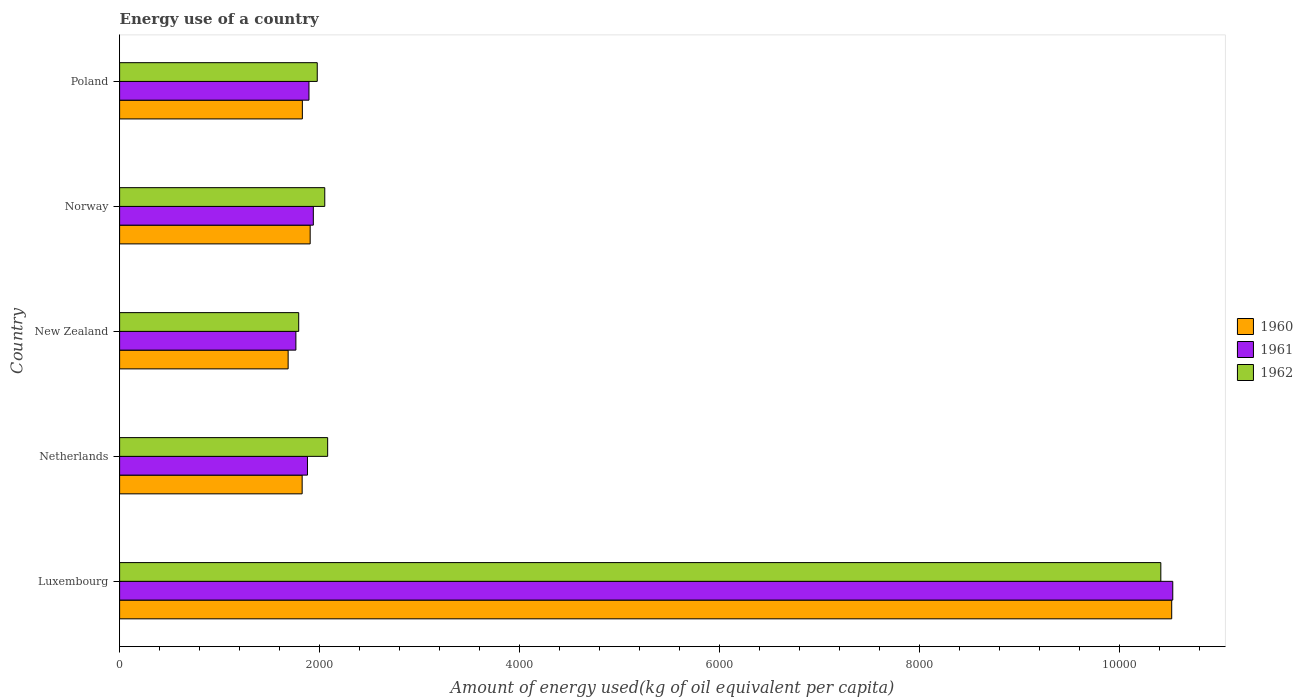How many groups of bars are there?
Provide a short and direct response. 5. Are the number of bars per tick equal to the number of legend labels?
Keep it short and to the point. Yes. Are the number of bars on each tick of the Y-axis equal?
Keep it short and to the point. Yes. How many bars are there on the 3rd tick from the top?
Offer a terse response. 3. In how many cases, is the number of bars for a given country not equal to the number of legend labels?
Offer a terse response. 0. What is the amount of energy used in in 1962 in Netherlands?
Make the answer very short. 2081.01. Across all countries, what is the maximum amount of energy used in in 1961?
Make the answer very short. 1.05e+04. Across all countries, what is the minimum amount of energy used in in 1960?
Offer a terse response. 1685.79. In which country was the amount of energy used in in 1960 maximum?
Provide a succinct answer. Luxembourg. In which country was the amount of energy used in in 1961 minimum?
Keep it short and to the point. New Zealand. What is the total amount of energy used in in 1960 in the graph?
Offer a very short reply. 1.78e+04. What is the difference between the amount of energy used in in 1960 in New Zealand and that in Norway?
Offer a very short reply. -220.39. What is the difference between the amount of energy used in in 1960 in Luxembourg and the amount of energy used in in 1961 in Norway?
Keep it short and to the point. 8585.76. What is the average amount of energy used in in 1961 per country?
Ensure brevity in your answer.  3601.63. What is the difference between the amount of energy used in in 1962 and amount of energy used in in 1961 in New Zealand?
Ensure brevity in your answer.  28.2. In how many countries, is the amount of energy used in in 1960 greater than 7600 kg?
Your answer should be compact. 1. What is the ratio of the amount of energy used in in 1960 in Norway to that in Poland?
Ensure brevity in your answer.  1.04. What is the difference between the highest and the second highest amount of energy used in in 1960?
Give a very brief answer. 8617.23. What is the difference between the highest and the lowest amount of energy used in in 1960?
Your response must be concise. 8837.62. Is the sum of the amount of energy used in in 1960 in Norway and Poland greater than the maximum amount of energy used in in 1961 across all countries?
Provide a succinct answer. No. What does the 1st bar from the top in Norway represents?
Offer a very short reply. 1962. How many bars are there?
Your answer should be compact. 15. How many countries are there in the graph?
Give a very brief answer. 5. What is the difference between two consecutive major ticks on the X-axis?
Offer a very short reply. 2000. Does the graph contain any zero values?
Ensure brevity in your answer.  No. Where does the legend appear in the graph?
Provide a short and direct response. Center right. What is the title of the graph?
Your response must be concise. Energy use of a country. Does "1972" appear as one of the legend labels in the graph?
Your answer should be very brief. No. What is the label or title of the X-axis?
Offer a very short reply. Amount of energy used(kg of oil equivalent per capita). What is the Amount of energy used(kg of oil equivalent per capita) in 1960 in Luxembourg?
Make the answer very short. 1.05e+04. What is the Amount of energy used(kg of oil equivalent per capita) of 1961 in Luxembourg?
Give a very brief answer. 1.05e+04. What is the Amount of energy used(kg of oil equivalent per capita) of 1962 in Luxembourg?
Keep it short and to the point. 1.04e+04. What is the Amount of energy used(kg of oil equivalent per capita) in 1960 in Netherlands?
Offer a very short reply. 1825.93. What is the Amount of energy used(kg of oil equivalent per capita) in 1961 in Netherlands?
Offer a very short reply. 1879.15. What is the Amount of energy used(kg of oil equivalent per capita) of 1962 in Netherlands?
Ensure brevity in your answer.  2081.01. What is the Amount of energy used(kg of oil equivalent per capita) in 1960 in New Zealand?
Provide a short and direct response. 1685.79. What is the Amount of energy used(kg of oil equivalent per capita) in 1961 in New Zealand?
Your answer should be very brief. 1763.26. What is the Amount of energy used(kg of oil equivalent per capita) in 1962 in New Zealand?
Make the answer very short. 1791.46. What is the Amount of energy used(kg of oil equivalent per capita) of 1960 in Norway?
Offer a terse response. 1906.17. What is the Amount of energy used(kg of oil equivalent per capita) of 1961 in Norway?
Your response must be concise. 1937.64. What is the Amount of energy used(kg of oil equivalent per capita) in 1962 in Norway?
Make the answer very short. 2052.05. What is the Amount of energy used(kg of oil equivalent per capita) of 1960 in Poland?
Provide a succinct answer. 1827.94. What is the Amount of energy used(kg of oil equivalent per capita) in 1961 in Poland?
Give a very brief answer. 1894.06. What is the Amount of energy used(kg of oil equivalent per capita) of 1962 in Poland?
Ensure brevity in your answer.  1976.86. Across all countries, what is the maximum Amount of energy used(kg of oil equivalent per capita) in 1960?
Offer a terse response. 1.05e+04. Across all countries, what is the maximum Amount of energy used(kg of oil equivalent per capita) of 1961?
Your answer should be compact. 1.05e+04. Across all countries, what is the maximum Amount of energy used(kg of oil equivalent per capita) of 1962?
Your response must be concise. 1.04e+04. Across all countries, what is the minimum Amount of energy used(kg of oil equivalent per capita) in 1960?
Offer a very short reply. 1685.79. Across all countries, what is the minimum Amount of energy used(kg of oil equivalent per capita) in 1961?
Keep it short and to the point. 1763.26. Across all countries, what is the minimum Amount of energy used(kg of oil equivalent per capita) in 1962?
Provide a short and direct response. 1791.46. What is the total Amount of energy used(kg of oil equivalent per capita) of 1960 in the graph?
Give a very brief answer. 1.78e+04. What is the total Amount of energy used(kg of oil equivalent per capita) in 1961 in the graph?
Ensure brevity in your answer.  1.80e+04. What is the total Amount of energy used(kg of oil equivalent per capita) of 1962 in the graph?
Provide a succinct answer. 1.83e+04. What is the difference between the Amount of energy used(kg of oil equivalent per capita) of 1960 in Luxembourg and that in Netherlands?
Give a very brief answer. 8697.47. What is the difference between the Amount of energy used(kg of oil equivalent per capita) of 1961 in Luxembourg and that in Netherlands?
Your answer should be very brief. 8654.87. What is the difference between the Amount of energy used(kg of oil equivalent per capita) in 1962 in Luxembourg and that in Netherlands?
Offer a terse response. 8333.53. What is the difference between the Amount of energy used(kg of oil equivalent per capita) in 1960 in Luxembourg and that in New Zealand?
Give a very brief answer. 8837.62. What is the difference between the Amount of energy used(kg of oil equivalent per capita) of 1961 in Luxembourg and that in New Zealand?
Ensure brevity in your answer.  8770.76. What is the difference between the Amount of energy used(kg of oil equivalent per capita) in 1962 in Luxembourg and that in New Zealand?
Offer a terse response. 8623.08. What is the difference between the Amount of energy used(kg of oil equivalent per capita) in 1960 in Luxembourg and that in Norway?
Give a very brief answer. 8617.23. What is the difference between the Amount of energy used(kg of oil equivalent per capita) of 1961 in Luxembourg and that in Norway?
Keep it short and to the point. 8596.37. What is the difference between the Amount of energy used(kg of oil equivalent per capita) in 1962 in Luxembourg and that in Norway?
Your response must be concise. 8362.49. What is the difference between the Amount of energy used(kg of oil equivalent per capita) in 1960 in Luxembourg and that in Poland?
Give a very brief answer. 8695.47. What is the difference between the Amount of energy used(kg of oil equivalent per capita) in 1961 in Luxembourg and that in Poland?
Your response must be concise. 8639.96. What is the difference between the Amount of energy used(kg of oil equivalent per capita) in 1962 in Luxembourg and that in Poland?
Ensure brevity in your answer.  8437.68. What is the difference between the Amount of energy used(kg of oil equivalent per capita) in 1960 in Netherlands and that in New Zealand?
Keep it short and to the point. 140.15. What is the difference between the Amount of energy used(kg of oil equivalent per capita) of 1961 in Netherlands and that in New Zealand?
Ensure brevity in your answer.  115.89. What is the difference between the Amount of energy used(kg of oil equivalent per capita) of 1962 in Netherlands and that in New Zealand?
Your answer should be very brief. 289.55. What is the difference between the Amount of energy used(kg of oil equivalent per capita) of 1960 in Netherlands and that in Norway?
Offer a very short reply. -80.24. What is the difference between the Amount of energy used(kg of oil equivalent per capita) of 1961 in Netherlands and that in Norway?
Your answer should be compact. -58.49. What is the difference between the Amount of energy used(kg of oil equivalent per capita) in 1962 in Netherlands and that in Norway?
Offer a very short reply. 28.96. What is the difference between the Amount of energy used(kg of oil equivalent per capita) in 1960 in Netherlands and that in Poland?
Your response must be concise. -2. What is the difference between the Amount of energy used(kg of oil equivalent per capita) in 1961 in Netherlands and that in Poland?
Your response must be concise. -14.91. What is the difference between the Amount of energy used(kg of oil equivalent per capita) of 1962 in Netherlands and that in Poland?
Your answer should be very brief. 104.15. What is the difference between the Amount of energy used(kg of oil equivalent per capita) of 1960 in New Zealand and that in Norway?
Your answer should be compact. -220.39. What is the difference between the Amount of energy used(kg of oil equivalent per capita) of 1961 in New Zealand and that in Norway?
Offer a terse response. -174.38. What is the difference between the Amount of energy used(kg of oil equivalent per capita) of 1962 in New Zealand and that in Norway?
Give a very brief answer. -260.59. What is the difference between the Amount of energy used(kg of oil equivalent per capita) in 1960 in New Zealand and that in Poland?
Provide a short and direct response. -142.15. What is the difference between the Amount of energy used(kg of oil equivalent per capita) of 1961 in New Zealand and that in Poland?
Offer a terse response. -130.8. What is the difference between the Amount of energy used(kg of oil equivalent per capita) in 1962 in New Zealand and that in Poland?
Provide a succinct answer. -185.4. What is the difference between the Amount of energy used(kg of oil equivalent per capita) in 1960 in Norway and that in Poland?
Give a very brief answer. 78.24. What is the difference between the Amount of energy used(kg of oil equivalent per capita) of 1961 in Norway and that in Poland?
Provide a short and direct response. 43.59. What is the difference between the Amount of energy used(kg of oil equivalent per capita) of 1962 in Norway and that in Poland?
Provide a short and direct response. 75.19. What is the difference between the Amount of energy used(kg of oil equivalent per capita) in 1960 in Luxembourg and the Amount of energy used(kg of oil equivalent per capita) in 1961 in Netherlands?
Provide a short and direct response. 8644.26. What is the difference between the Amount of energy used(kg of oil equivalent per capita) in 1960 in Luxembourg and the Amount of energy used(kg of oil equivalent per capita) in 1962 in Netherlands?
Your response must be concise. 8442.4. What is the difference between the Amount of energy used(kg of oil equivalent per capita) in 1961 in Luxembourg and the Amount of energy used(kg of oil equivalent per capita) in 1962 in Netherlands?
Provide a succinct answer. 8453.01. What is the difference between the Amount of energy used(kg of oil equivalent per capita) of 1960 in Luxembourg and the Amount of energy used(kg of oil equivalent per capita) of 1961 in New Zealand?
Your answer should be very brief. 8760.15. What is the difference between the Amount of energy used(kg of oil equivalent per capita) of 1960 in Luxembourg and the Amount of energy used(kg of oil equivalent per capita) of 1962 in New Zealand?
Your response must be concise. 8731.95. What is the difference between the Amount of energy used(kg of oil equivalent per capita) of 1961 in Luxembourg and the Amount of energy used(kg of oil equivalent per capita) of 1962 in New Zealand?
Keep it short and to the point. 8742.56. What is the difference between the Amount of energy used(kg of oil equivalent per capita) of 1960 in Luxembourg and the Amount of energy used(kg of oil equivalent per capita) of 1961 in Norway?
Give a very brief answer. 8585.76. What is the difference between the Amount of energy used(kg of oil equivalent per capita) in 1960 in Luxembourg and the Amount of energy used(kg of oil equivalent per capita) in 1962 in Norway?
Provide a short and direct response. 8471.35. What is the difference between the Amount of energy used(kg of oil equivalent per capita) in 1961 in Luxembourg and the Amount of energy used(kg of oil equivalent per capita) in 1962 in Norway?
Provide a succinct answer. 8481.96. What is the difference between the Amount of energy used(kg of oil equivalent per capita) in 1960 in Luxembourg and the Amount of energy used(kg of oil equivalent per capita) in 1961 in Poland?
Keep it short and to the point. 8629.35. What is the difference between the Amount of energy used(kg of oil equivalent per capita) in 1960 in Luxembourg and the Amount of energy used(kg of oil equivalent per capita) in 1962 in Poland?
Offer a terse response. 8546.55. What is the difference between the Amount of energy used(kg of oil equivalent per capita) of 1961 in Luxembourg and the Amount of energy used(kg of oil equivalent per capita) of 1962 in Poland?
Your response must be concise. 8557.16. What is the difference between the Amount of energy used(kg of oil equivalent per capita) in 1960 in Netherlands and the Amount of energy used(kg of oil equivalent per capita) in 1961 in New Zealand?
Provide a short and direct response. 62.67. What is the difference between the Amount of energy used(kg of oil equivalent per capita) of 1960 in Netherlands and the Amount of energy used(kg of oil equivalent per capita) of 1962 in New Zealand?
Make the answer very short. 34.47. What is the difference between the Amount of energy used(kg of oil equivalent per capita) in 1961 in Netherlands and the Amount of energy used(kg of oil equivalent per capita) in 1962 in New Zealand?
Keep it short and to the point. 87.69. What is the difference between the Amount of energy used(kg of oil equivalent per capita) of 1960 in Netherlands and the Amount of energy used(kg of oil equivalent per capita) of 1961 in Norway?
Your answer should be compact. -111.71. What is the difference between the Amount of energy used(kg of oil equivalent per capita) of 1960 in Netherlands and the Amount of energy used(kg of oil equivalent per capita) of 1962 in Norway?
Your answer should be very brief. -226.12. What is the difference between the Amount of energy used(kg of oil equivalent per capita) of 1961 in Netherlands and the Amount of energy used(kg of oil equivalent per capita) of 1962 in Norway?
Your answer should be very brief. -172.9. What is the difference between the Amount of energy used(kg of oil equivalent per capita) in 1960 in Netherlands and the Amount of energy used(kg of oil equivalent per capita) in 1961 in Poland?
Make the answer very short. -68.12. What is the difference between the Amount of energy used(kg of oil equivalent per capita) of 1960 in Netherlands and the Amount of energy used(kg of oil equivalent per capita) of 1962 in Poland?
Your response must be concise. -150.93. What is the difference between the Amount of energy used(kg of oil equivalent per capita) in 1961 in Netherlands and the Amount of energy used(kg of oil equivalent per capita) in 1962 in Poland?
Your answer should be compact. -97.71. What is the difference between the Amount of energy used(kg of oil equivalent per capita) of 1960 in New Zealand and the Amount of energy used(kg of oil equivalent per capita) of 1961 in Norway?
Your answer should be compact. -251.86. What is the difference between the Amount of energy used(kg of oil equivalent per capita) of 1960 in New Zealand and the Amount of energy used(kg of oil equivalent per capita) of 1962 in Norway?
Your answer should be compact. -366.27. What is the difference between the Amount of energy used(kg of oil equivalent per capita) in 1961 in New Zealand and the Amount of energy used(kg of oil equivalent per capita) in 1962 in Norway?
Give a very brief answer. -288.79. What is the difference between the Amount of energy used(kg of oil equivalent per capita) of 1960 in New Zealand and the Amount of energy used(kg of oil equivalent per capita) of 1961 in Poland?
Your answer should be very brief. -208.27. What is the difference between the Amount of energy used(kg of oil equivalent per capita) of 1960 in New Zealand and the Amount of energy used(kg of oil equivalent per capita) of 1962 in Poland?
Keep it short and to the point. -291.07. What is the difference between the Amount of energy used(kg of oil equivalent per capita) in 1961 in New Zealand and the Amount of energy used(kg of oil equivalent per capita) in 1962 in Poland?
Keep it short and to the point. -213.6. What is the difference between the Amount of energy used(kg of oil equivalent per capita) of 1960 in Norway and the Amount of energy used(kg of oil equivalent per capita) of 1961 in Poland?
Your answer should be very brief. 12.12. What is the difference between the Amount of energy used(kg of oil equivalent per capita) of 1960 in Norway and the Amount of energy used(kg of oil equivalent per capita) of 1962 in Poland?
Offer a terse response. -70.68. What is the difference between the Amount of energy used(kg of oil equivalent per capita) of 1961 in Norway and the Amount of energy used(kg of oil equivalent per capita) of 1962 in Poland?
Offer a very short reply. -39.22. What is the average Amount of energy used(kg of oil equivalent per capita) in 1960 per country?
Keep it short and to the point. 3553.85. What is the average Amount of energy used(kg of oil equivalent per capita) in 1961 per country?
Provide a succinct answer. 3601.63. What is the average Amount of energy used(kg of oil equivalent per capita) of 1962 per country?
Provide a short and direct response. 3663.19. What is the difference between the Amount of energy used(kg of oil equivalent per capita) in 1960 and Amount of energy used(kg of oil equivalent per capita) in 1961 in Luxembourg?
Keep it short and to the point. -10.61. What is the difference between the Amount of energy used(kg of oil equivalent per capita) in 1960 and Amount of energy used(kg of oil equivalent per capita) in 1962 in Luxembourg?
Provide a succinct answer. 108.87. What is the difference between the Amount of energy used(kg of oil equivalent per capita) in 1961 and Amount of energy used(kg of oil equivalent per capita) in 1962 in Luxembourg?
Offer a very short reply. 119.48. What is the difference between the Amount of energy used(kg of oil equivalent per capita) in 1960 and Amount of energy used(kg of oil equivalent per capita) in 1961 in Netherlands?
Provide a short and direct response. -53.22. What is the difference between the Amount of energy used(kg of oil equivalent per capita) in 1960 and Amount of energy used(kg of oil equivalent per capita) in 1962 in Netherlands?
Make the answer very short. -255.08. What is the difference between the Amount of energy used(kg of oil equivalent per capita) in 1961 and Amount of energy used(kg of oil equivalent per capita) in 1962 in Netherlands?
Make the answer very short. -201.86. What is the difference between the Amount of energy used(kg of oil equivalent per capita) of 1960 and Amount of energy used(kg of oil equivalent per capita) of 1961 in New Zealand?
Make the answer very short. -77.47. What is the difference between the Amount of energy used(kg of oil equivalent per capita) of 1960 and Amount of energy used(kg of oil equivalent per capita) of 1962 in New Zealand?
Ensure brevity in your answer.  -105.67. What is the difference between the Amount of energy used(kg of oil equivalent per capita) in 1961 and Amount of energy used(kg of oil equivalent per capita) in 1962 in New Zealand?
Offer a very short reply. -28.2. What is the difference between the Amount of energy used(kg of oil equivalent per capita) of 1960 and Amount of energy used(kg of oil equivalent per capita) of 1961 in Norway?
Your answer should be compact. -31.47. What is the difference between the Amount of energy used(kg of oil equivalent per capita) in 1960 and Amount of energy used(kg of oil equivalent per capita) in 1962 in Norway?
Keep it short and to the point. -145.88. What is the difference between the Amount of energy used(kg of oil equivalent per capita) of 1961 and Amount of energy used(kg of oil equivalent per capita) of 1962 in Norway?
Provide a short and direct response. -114.41. What is the difference between the Amount of energy used(kg of oil equivalent per capita) in 1960 and Amount of energy used(kg of oil equivalent per capita) in 1961 in Poland?
Provide a short and direct response. -66.12. What is the difference between the Amount of energy used(kg of oil equivalent per capita) of 1960 and Amount of energy used(kg of oil equivalent per capita) of 1962 in Poland?
Make the answer very short. -148.92. What is the difference between the Amount of energy used(kg of oil equivalent per capita) in 1961 and Amount of energy used(kg of oil equivalent per capita) in 1962 in Poland?
Offer a terse response. -82.8. What is the ratio of the Amount of energy used(kg of oil equivalent per capita) in 1960 in Luxembourg to that in Netherlands?
Your answer should be compact. 5.76. What is the ratio of the Amount of energy used(kg of oil equivalent per capita) in 1961 in Luxembourg to that in Netherlands?
Your response must be concise. 5.61. What is the ratio of the Amount of energy used(kg of oil equivalent per capita) in 1962 in Luxembourg to that in Netherlands?
Make the answer very short. 5. What is the ratio of the Amount of energy used(kg of oil equivalent per capita) of 1960 in Luxembourg to that in New Zealand?
Give a very brief answer. 6.24. What is the ratio of the Amount of energy used(kg of oil equivalent per capita) of 1961 in Luxembourg to that in New Zealand?
Your answer should be compact. 5.97. What is the ratio of the Amount of energy used(kg of oil equivalent per capita) in 1962 in Luxembourg to that in New Zealand?
Give a very brief answer. 5.81. What is the ratio of the Amount of energy used(kg of oil equivalent per capita) of 1960 in Luxembourg to that in Norway?
Keep it short and to the point. 5.52. What is the ratio of the Amount of energy used(kg of oil equivalent per capita) of 1961 in Luxembourg to that in Norway?
Make the answer very short. 5.44. What is the ratio of the Amount of energy used(kg of oil equivalent per capita) of 1962 in Luxembourg to that in Norway?
Keep it short and to the point. 5.08. What is the ratio of the Amount of energy used(kg of oil equivalent per capita) of 1960 in Luxembourg to that in Poland?
Offer a very short reply. 5.76. What is the ratio of the Amount of energy used(kg of oil equivalent per capita) of 1961 in Luxembourg to that in Poland?
Your answer should be compact. 5.56. What is the ratio of the Amount of energy used(kg of oil equivalent per capita) in 1962 in Luxembourg to that in Poland?
Keep it short and to the point. 5.27. What is the ratio of the Amount of energy used(kg of oil equivalent per capita) of 1960 in Netherlands to that in New Zealand?
Keep it short and to the point. 1.08. What is the ratio of the Amount of energy used(kg of oil equivalent per capita) of 1961 in Netherlands to that in New Zealand?
Your response must be concise. 1.07. What is the ratio of the Amount of energy used(kg of oil equivalent per capita) of 1962 in Netherlands to that in New Zealand?
Provide a short and direct response. 1.16. What is the ratio of the Amount of energy used(kg of oil equivalent per capita) of 1960 in Netherlands to that in Norway?
Ensure brevity in your answer.  0.96. What is the ratio of the Amount of energy used(kg of oil equivalent per capita) in 1961 in Netherlands to that in Norway?
Keep it short and to the point. 0.97. What is the ratio of the Amount of energy used(kg of oil equivalent per capita) of 1962 in Netherlands to that in Norway?
Provide a short and direct response. 1.01. What is the ratio of the Amount of energy used(kg of oil equivalent per capita) of 1960 in Netherlands to that in Poland?
Your answer should be compact. 1. What is the ratio of the Amount of energy used(kg of oil equivalent per capita) of 1961 in Netherlands to that in Poland?
Give a very brief answer. 0.99. What is the ratio of the Amount of energy used(kg of oil equivalent per capita) of 1962 in Netherlands to that in Poland?
Keep it short and to the point. 1.05. What is the ratio of the Amount of energy used(kg of oil equivalent per capita) of 1960 in New Zealand to that in Norway?
Offer a terse response. 0.88. What is the ratio of the Amount of energy used(kg of oil equivalent per capita) in 1961 in New Zealand to that in Norway?
Give a very brief answer. 0.91. What is the ratio of the Amount of energy used(kg of oil equivalent per capita) of 1962 in New Zealand to that in Norway?
Your response must be concise. 0.87. What is the ratio of the Amount of energy used(kg of oil equivalent per capita) in 1960 in New Zealand to that in Poland?
Offer a terse response. 0.92. What is the ratio of the Amount of energy used(kg of oil equivalent per capita) of 1961 in New Zealand to that in Poland?
Offer a very short reply. 0.93. What is the ratio of the Amount of energy used(kg of oil equivalent per capita) in 1962 in New Zealand to that in Poland?
Provide a short and direct response. 0.91. What is the ratio of the Amount of energy used(kg of oil equivalent per capita) of 1960 in Norway to that in Poland?
Your response must be concise. 1.04. What is the ratio of the Amount of energy used(kg of oil equivalent per capita) in 1962 in Norway to that in Poland?
Offer a very short reply. 1.04. What is the difference between the highest and the second highest Amount of energy used(kg of oil equivalent per capita) in 1960?
Provide a succinct answer. 8617.23. What is the difference between the highest and the second highest Amount of energy used(kg of oil equivalent per capita) of 1961?
Your answer should be compact. 8596.37. What is the difference between the highest and the second highest Amount of energy used(kg of oil equivalent per capita) in 1962?
Provide a short and direct response. 8333.53. What is the difference between the highest and the lowest Amount of energy used(kg of oil equivalent per capita) of 1960?
Your answer should be compact. 8837.62. What is the difference between the highest and the lowest Amount of energy used(kg of oil equivalent per capita) in 1961?
Offer a terse response. 8770.76. What is the difference between the highest and the lowest Amount of energy used(kg of oil equivalent per capita) in 1962?
Offer a terse response. 8623.08. 